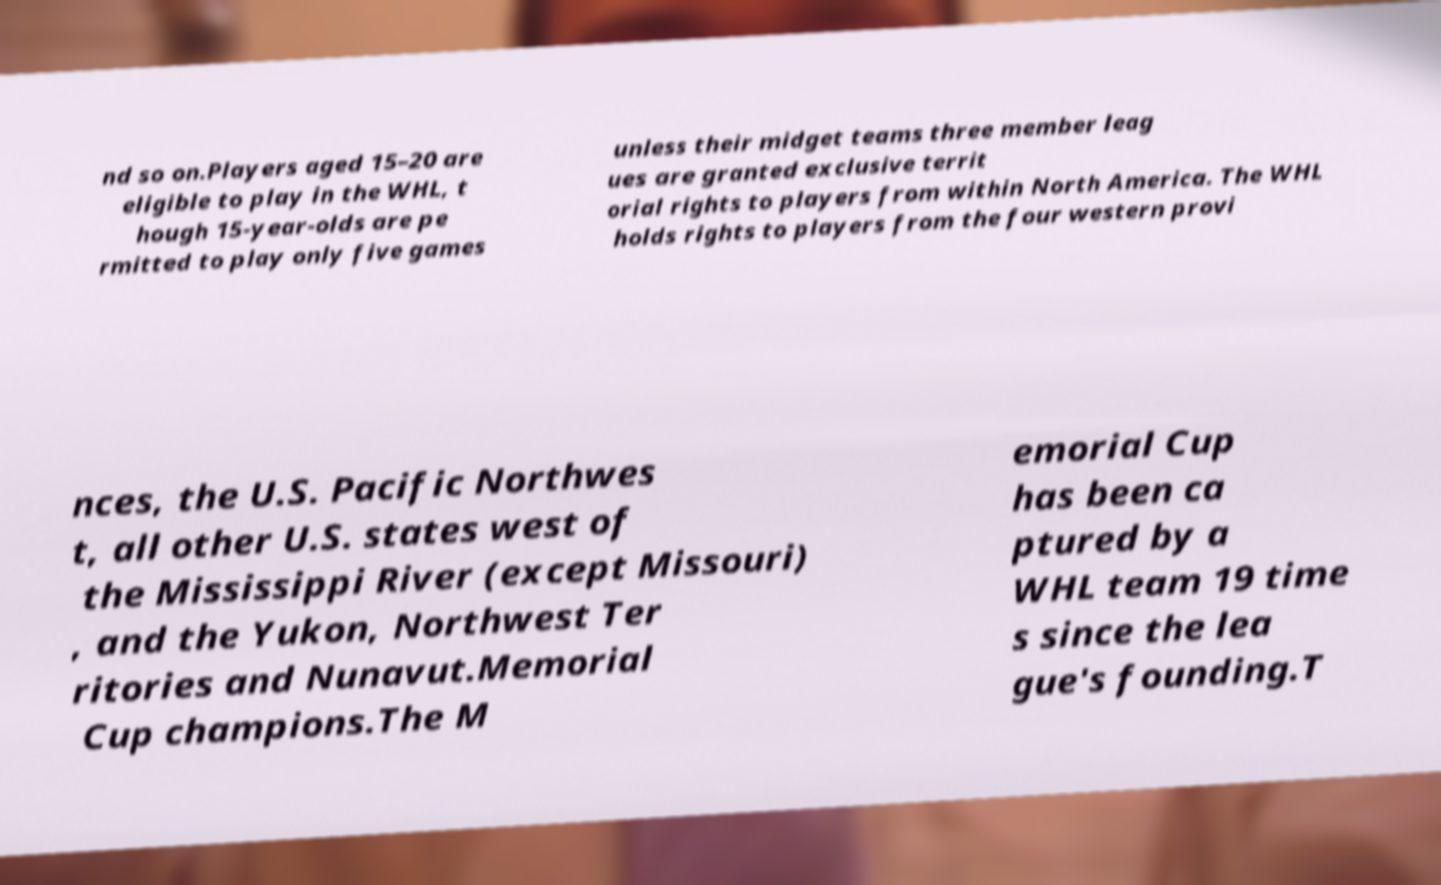There's text embedded in this image that I need extracted. Can you transcribe it verbatim? nd so on.Players aged 15–20 are eligible to play in the WHL, t hough 15-year-olds are pe rmitted to play only five games unless their midget teams three member leag ues are granted exclusive territ orial rights to players from within North America. The WHL holds rights to players from the four western provi nces, the U.S. Pacific Northwes t, all other U.S. states west of the Mississippi River (except Missouri) , and the Yukon, Northwest Ter ritories and Nunavut.Memorial Cup champions.The M emorial Cup has been ca ptured by a WHL team 19 time s since the lea gue's founding.T 